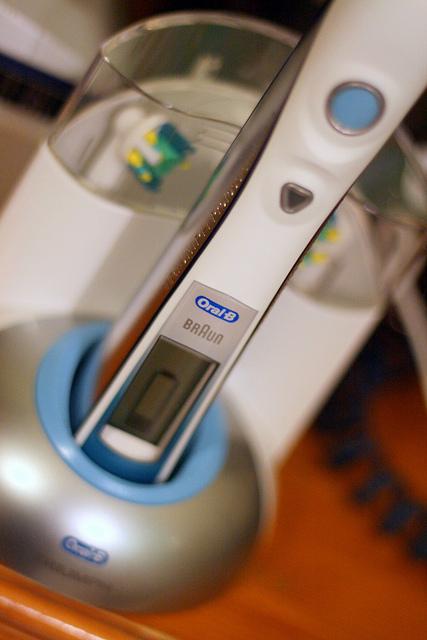What color is the wood?
Answer briefly. Brown. Is the battery low or high?
Be succinct. Low. What brand is this device?
Answer briefly. Oral b. 